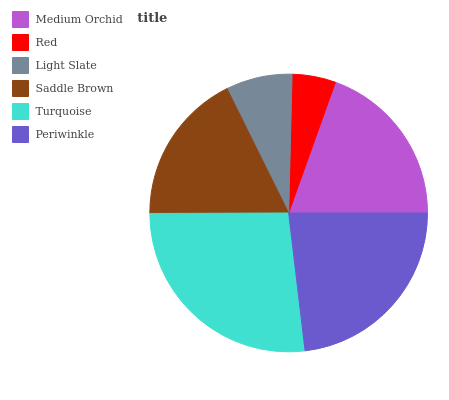Is Red the minimum?
Answer yes or no. Yes. Is Turquoise the maximum?
Answer yes or no. Yes. Is Light Slate the minimum?
Answer yes or no. No. Is Light Slate the maximum?
Answer yes or no. No. Is Light Slate greater than Red?
Answer yes or no. Yes. Is Red less than Light Slate?
Answer yes or no. Yes. Is Red greater than Light Slate?
Answer yes or no. No. Is Light Slate less than Red?
Answer yes or no. No. Is Medium Orchid the high median?
Answer yes or no. Yes. Is Saddle Brown the low median?
Answer yes or no. Yes. Is Saddle Brown the high median?
Answer yes or no. No. Is Turquoise the low median?
Answer yes or no. No. 